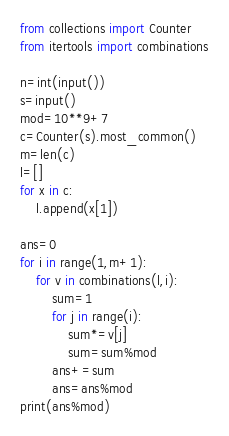Convert code to text. <code><loc_0><loc_0><loc_500><loc_500><_Python_>from collections import Counter
from itertools import combinations

n=int(input())
s=input()
mod=10**9+7
c=Counter(s).most_common()
m=len(c)
l=[]
for x in c:
    l.append(x[1])

ans=0
for i in range(1,m+1):
    for v in combinations(l,i):
        sum=1
        for j in range(i):
            sum*=v[j]
            sum=sum%mod
        ans+=sum
        ans=ans%mod
print(ans%mod)</code> 